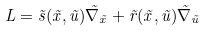<formula> <loc_0><loc_0><loc_500><loc_500>L = \vec { s } ( \vec { x } , \vec { u } ) \vec { \nabla } _ { \vec { x } } + \vec { r } ( \vec { x } , \vec { u } ) \vec { \nabla } _ { \vec { u } }</formula> 